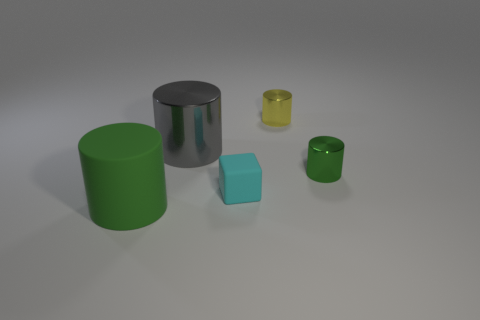Subtract all gray cylinders. How many cylinders are left? 3 Subtract all cyan blocks. How many green cylinders are left? 2 Add 5 big yellow rubber cylinders. How many objects exist? 10 Subtract 1 cylinders. How many cylinders are left? 3 Subtract all gray cylinders. How many cylinders are left? 3 Subtract all blocks. How many objects are left? 4 Add 4 yellow cylinders. How many yellow cylinders are left? 5 Add 3 large green things. How many large green things exist? 4 Subtract 0 gray spheres. How many objects are left? 5 Subtract all purple cylinders. Subtract all yellow spheres. How many cylinders are left? 4 